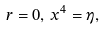<formula> <loc_0><loc_0><loc_500><loc_500>r = 0 , \, x ^ { 4 } = \eta ,</formula> 